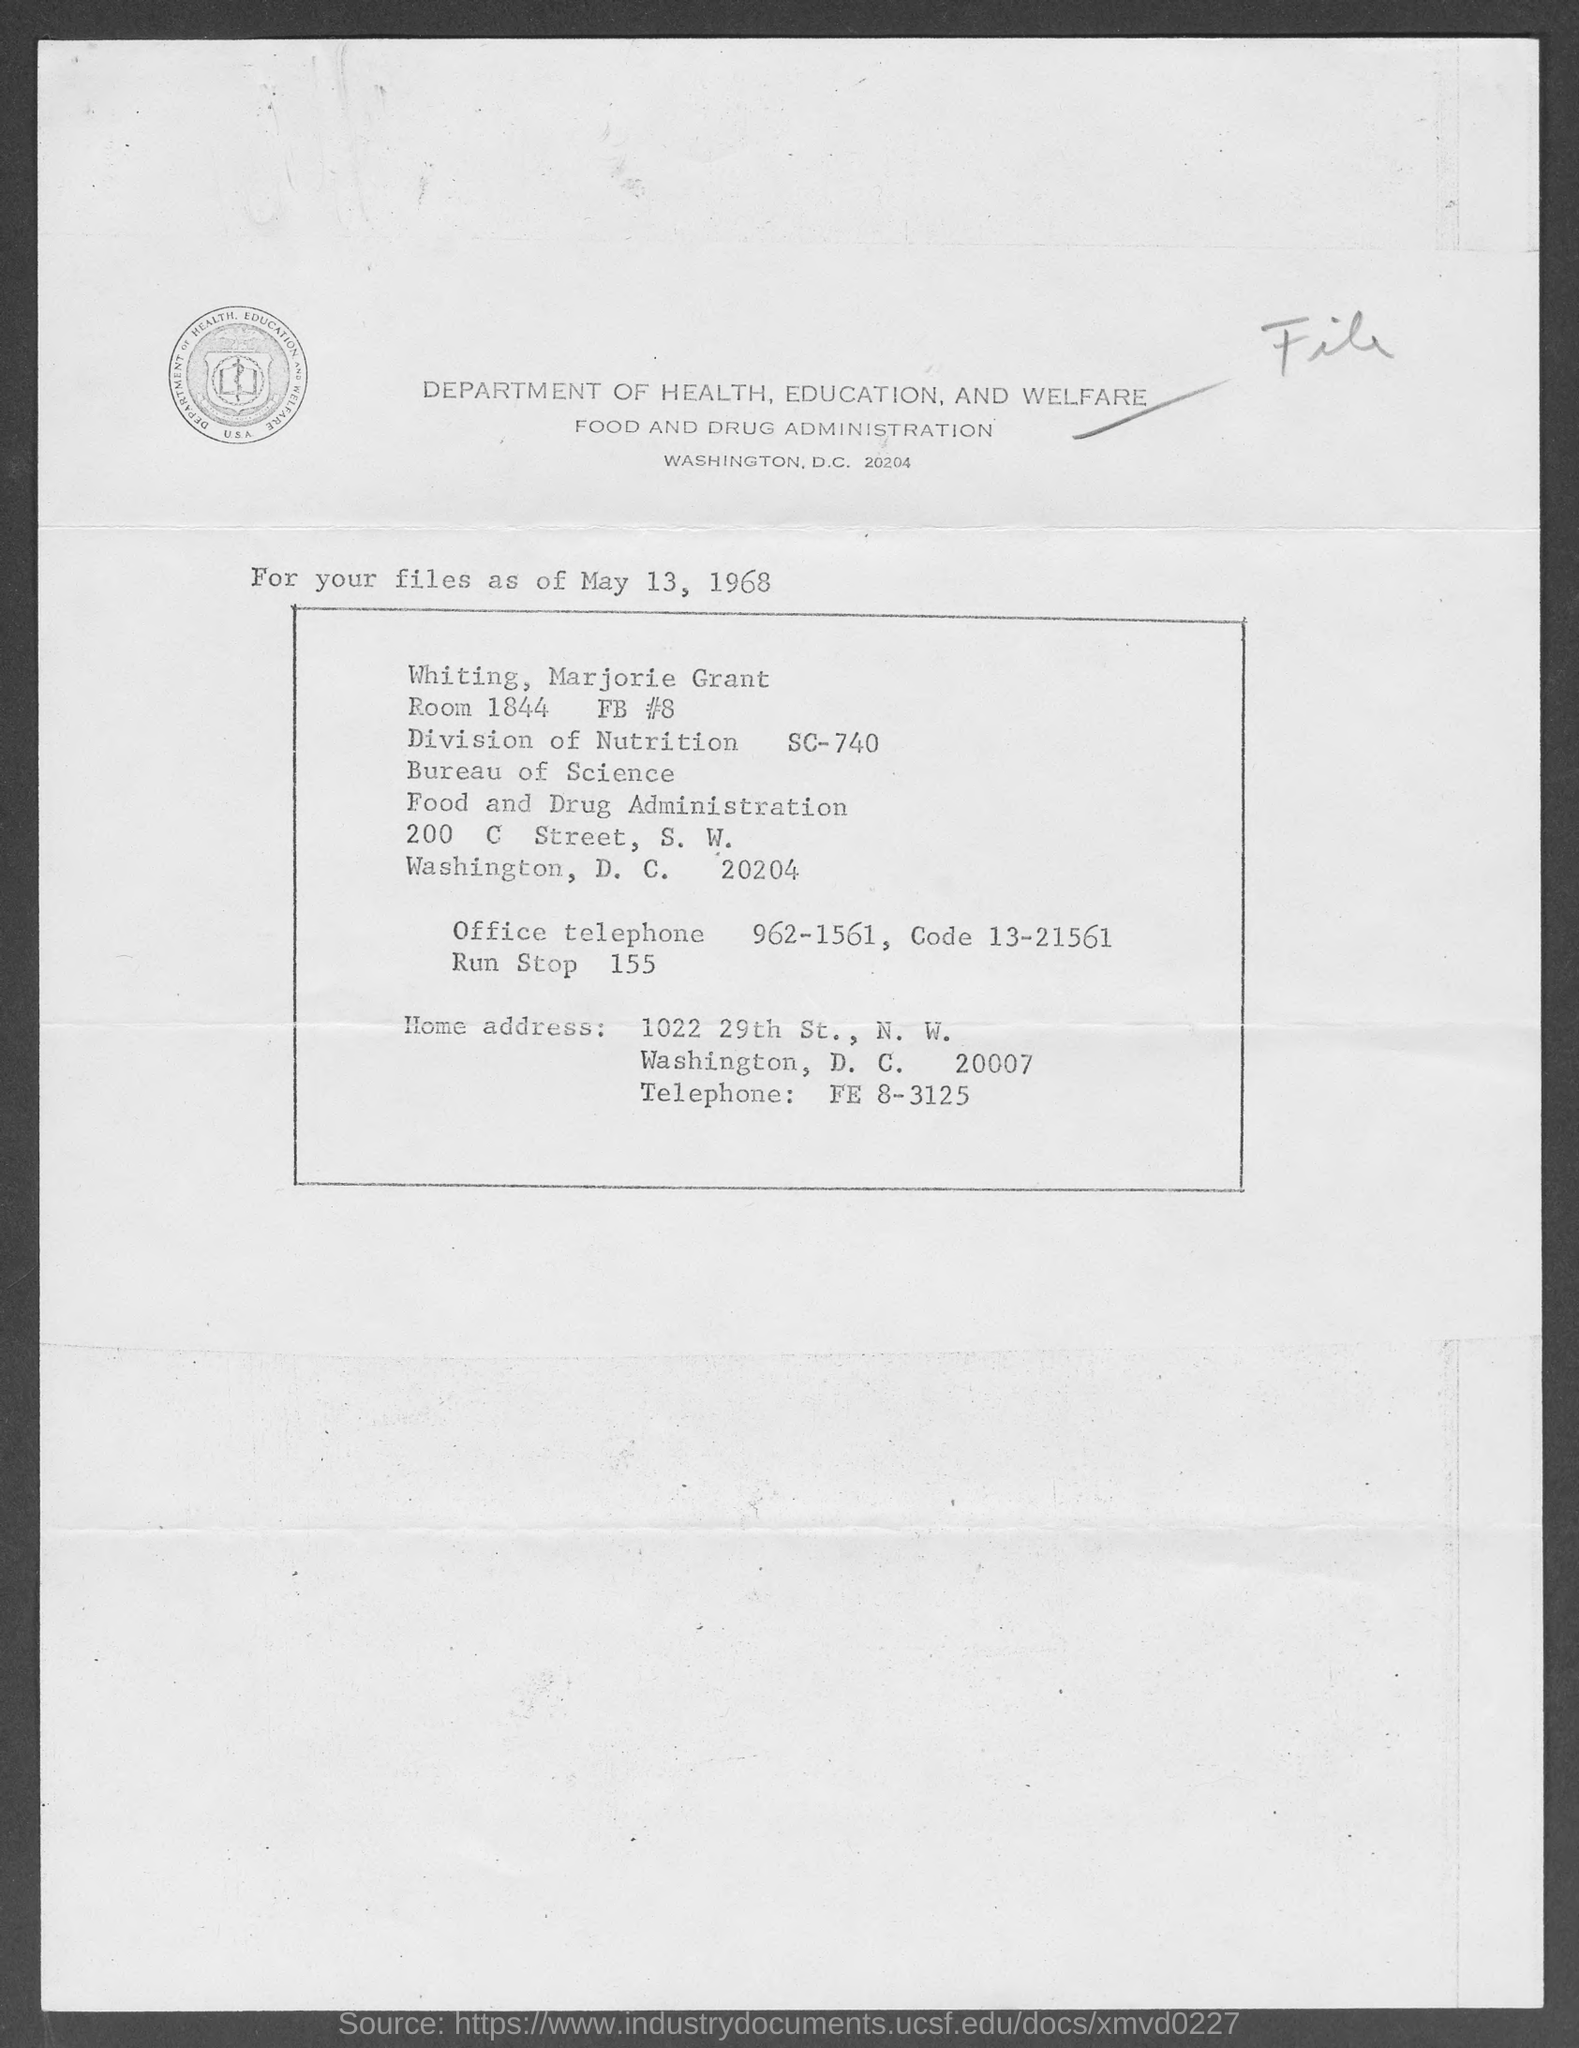What is the date on the document?
Make the answer very short. May 13, 1968. What is the Office Telephone?
Keep it short and to the point. 962-1561. What is the code?
Give a very brief answer. 13-21561. What is the Run stop?
Keep it short and to the point. 155. What is the room Number?
Offer a very short reply. 1844. 